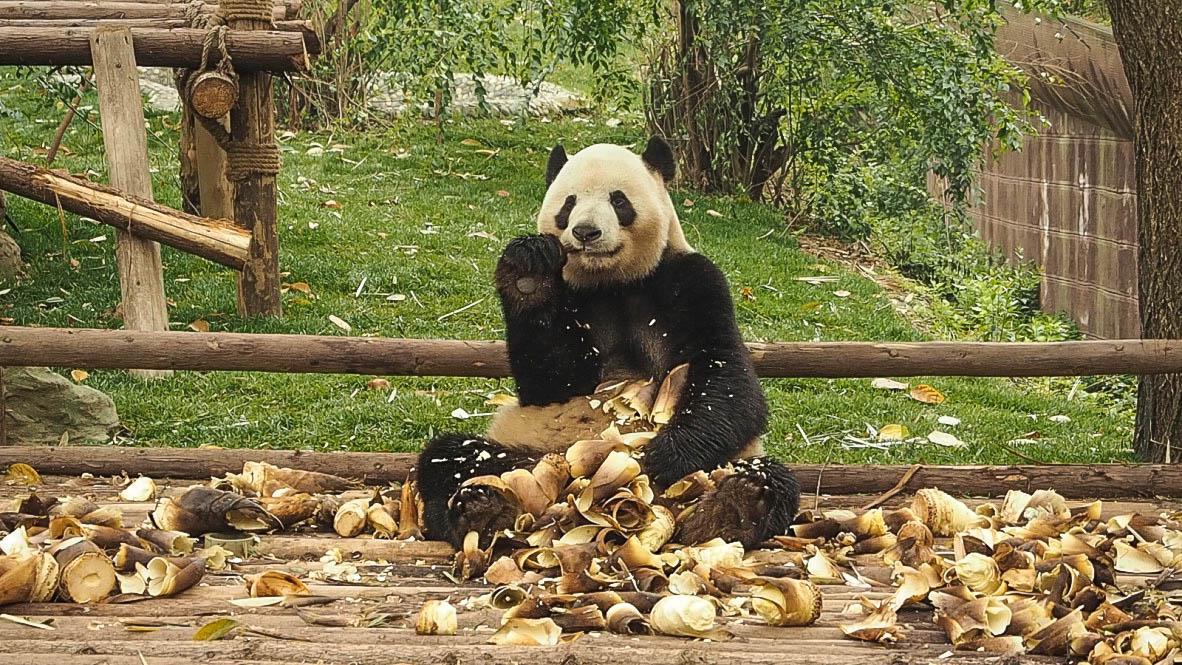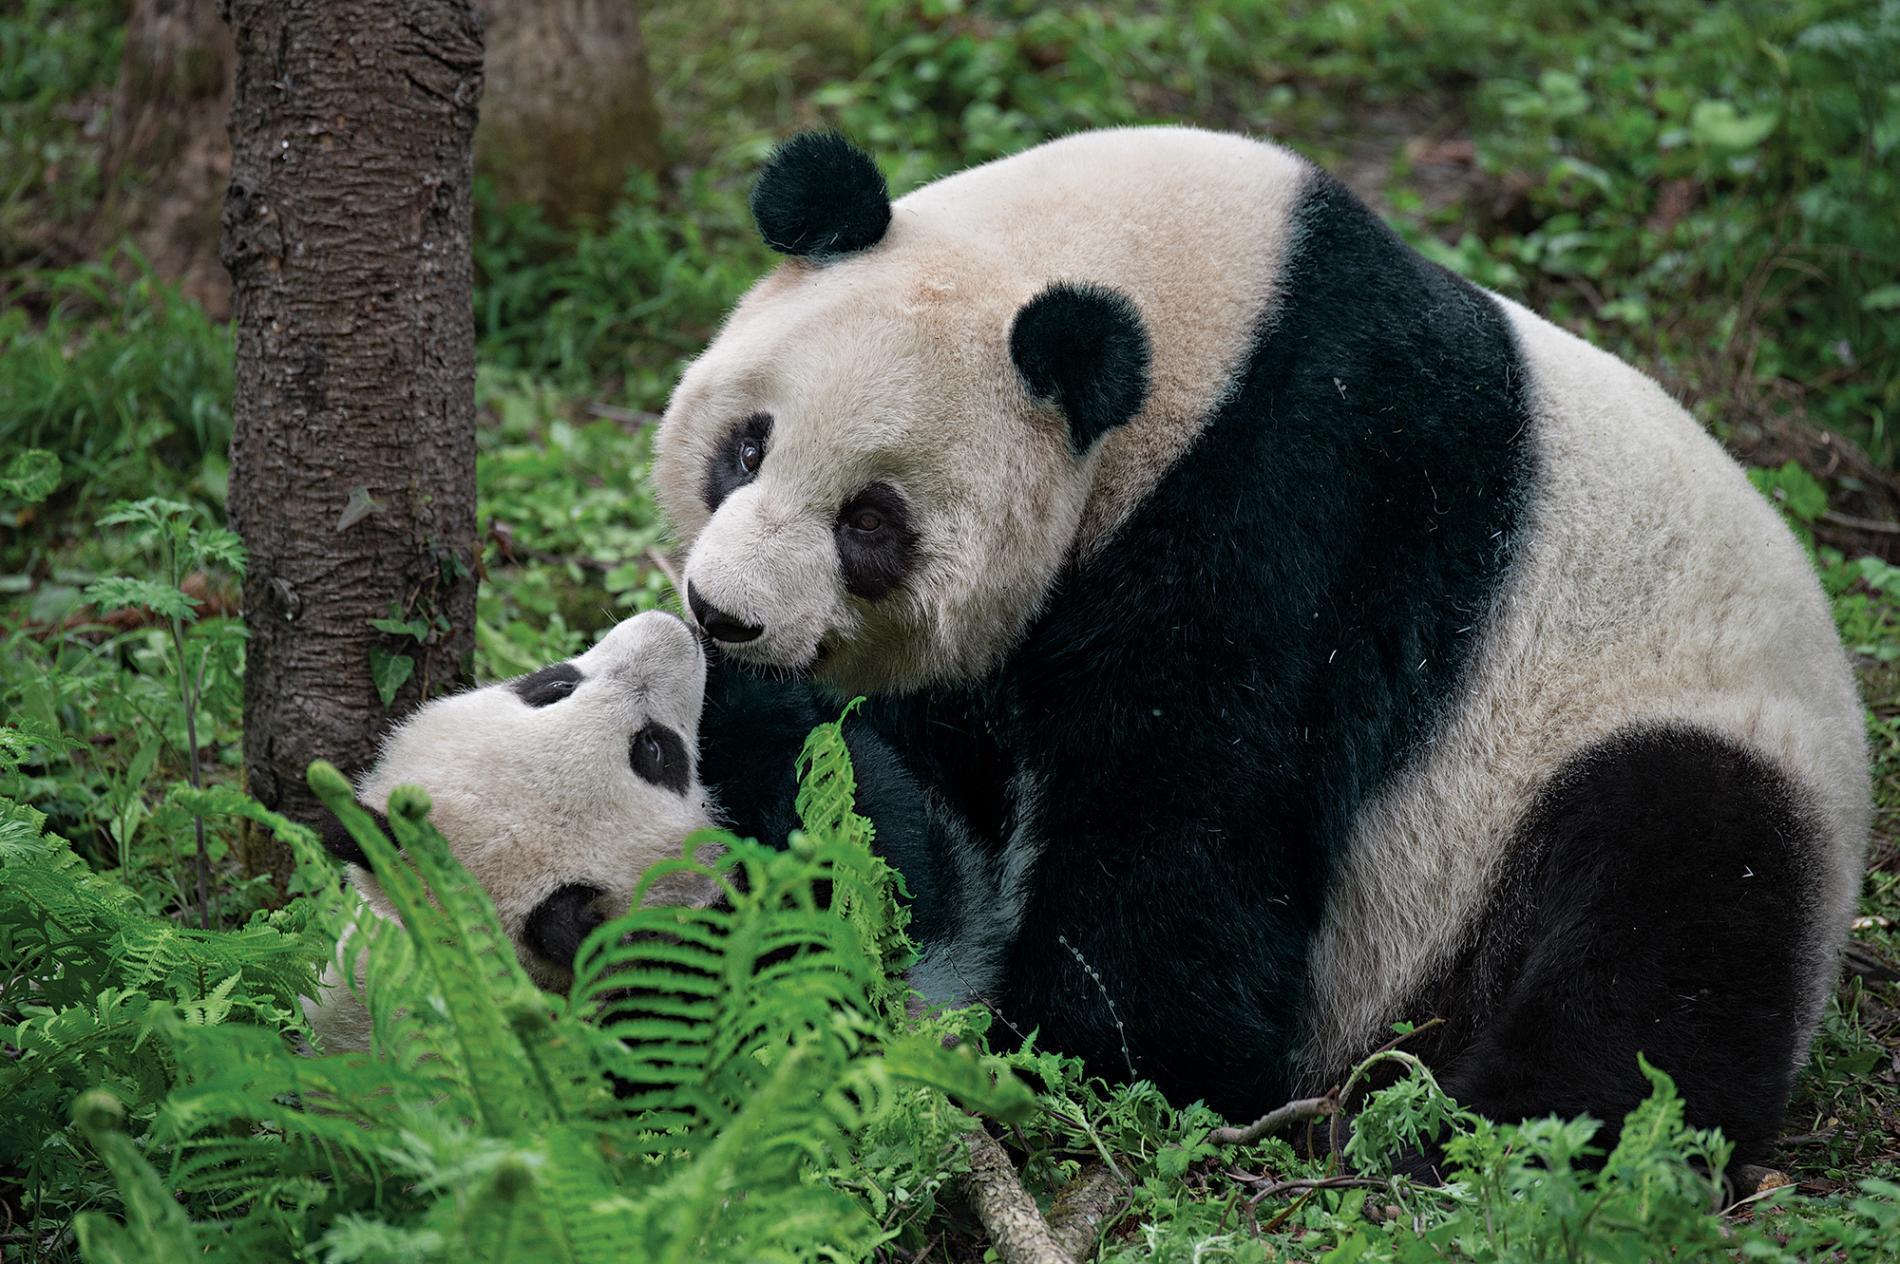The first image is the image on the left, the second image is the image on the right. Examine the images to the left and right. Is the description "No image contains more than three pandas, one image contains a single panda, and a structure made of horizontal wooden poles is pictured in an image." accurate? Answer yes or no. Yes. The first image is the image on the left, the second image is the image on the right. For the images shown, is this caption "There are no more than four panda bears." true? Answer yes or no. Yes. 